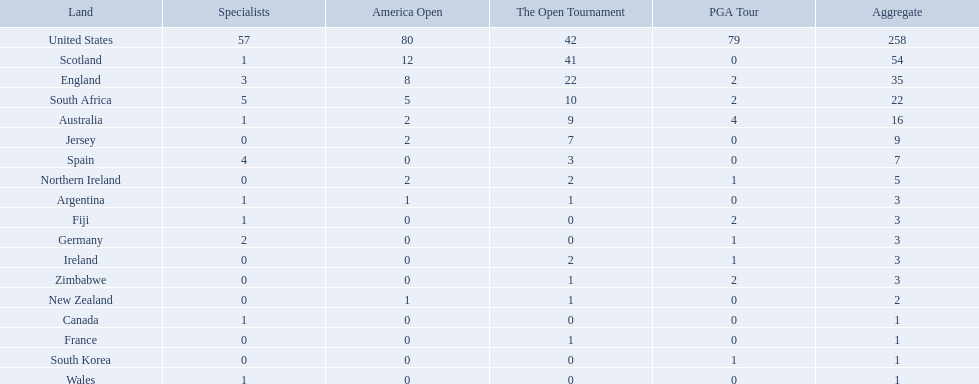How many u.s. open wins does fiji have? 0. 